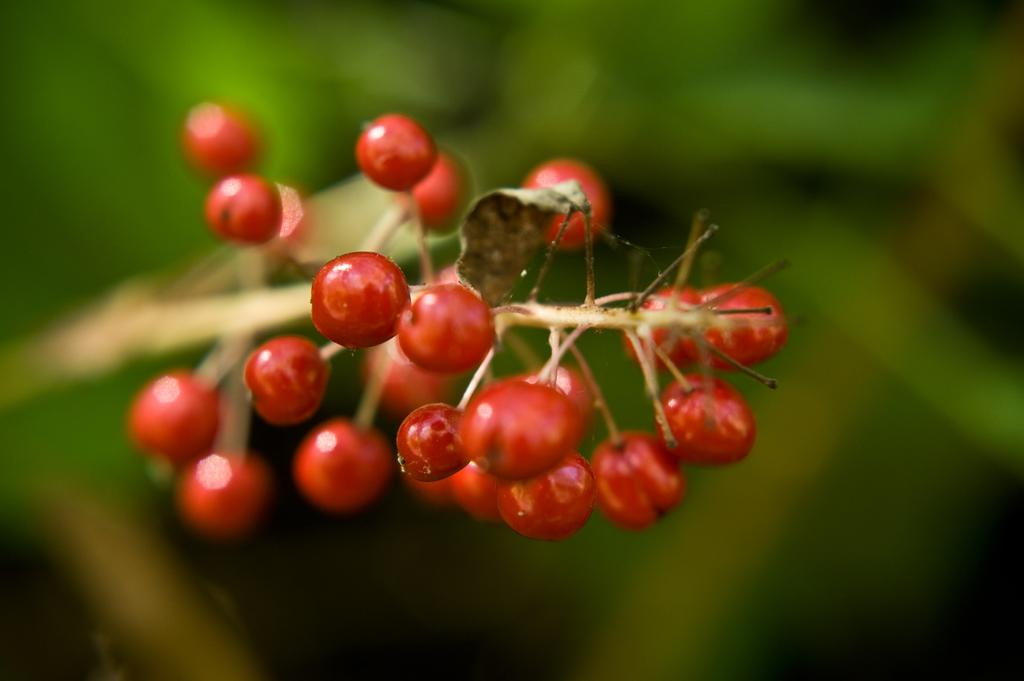What color are the fruits in the image? The fruits in the image are red. What part of the fruit is visible in the image? There is a leaf on the stem in the image. How would you describe the background of the image? The background of the image is blurred. Is there a maid holding a sponge in the image? No, there is no maid or sponge present in the image. 